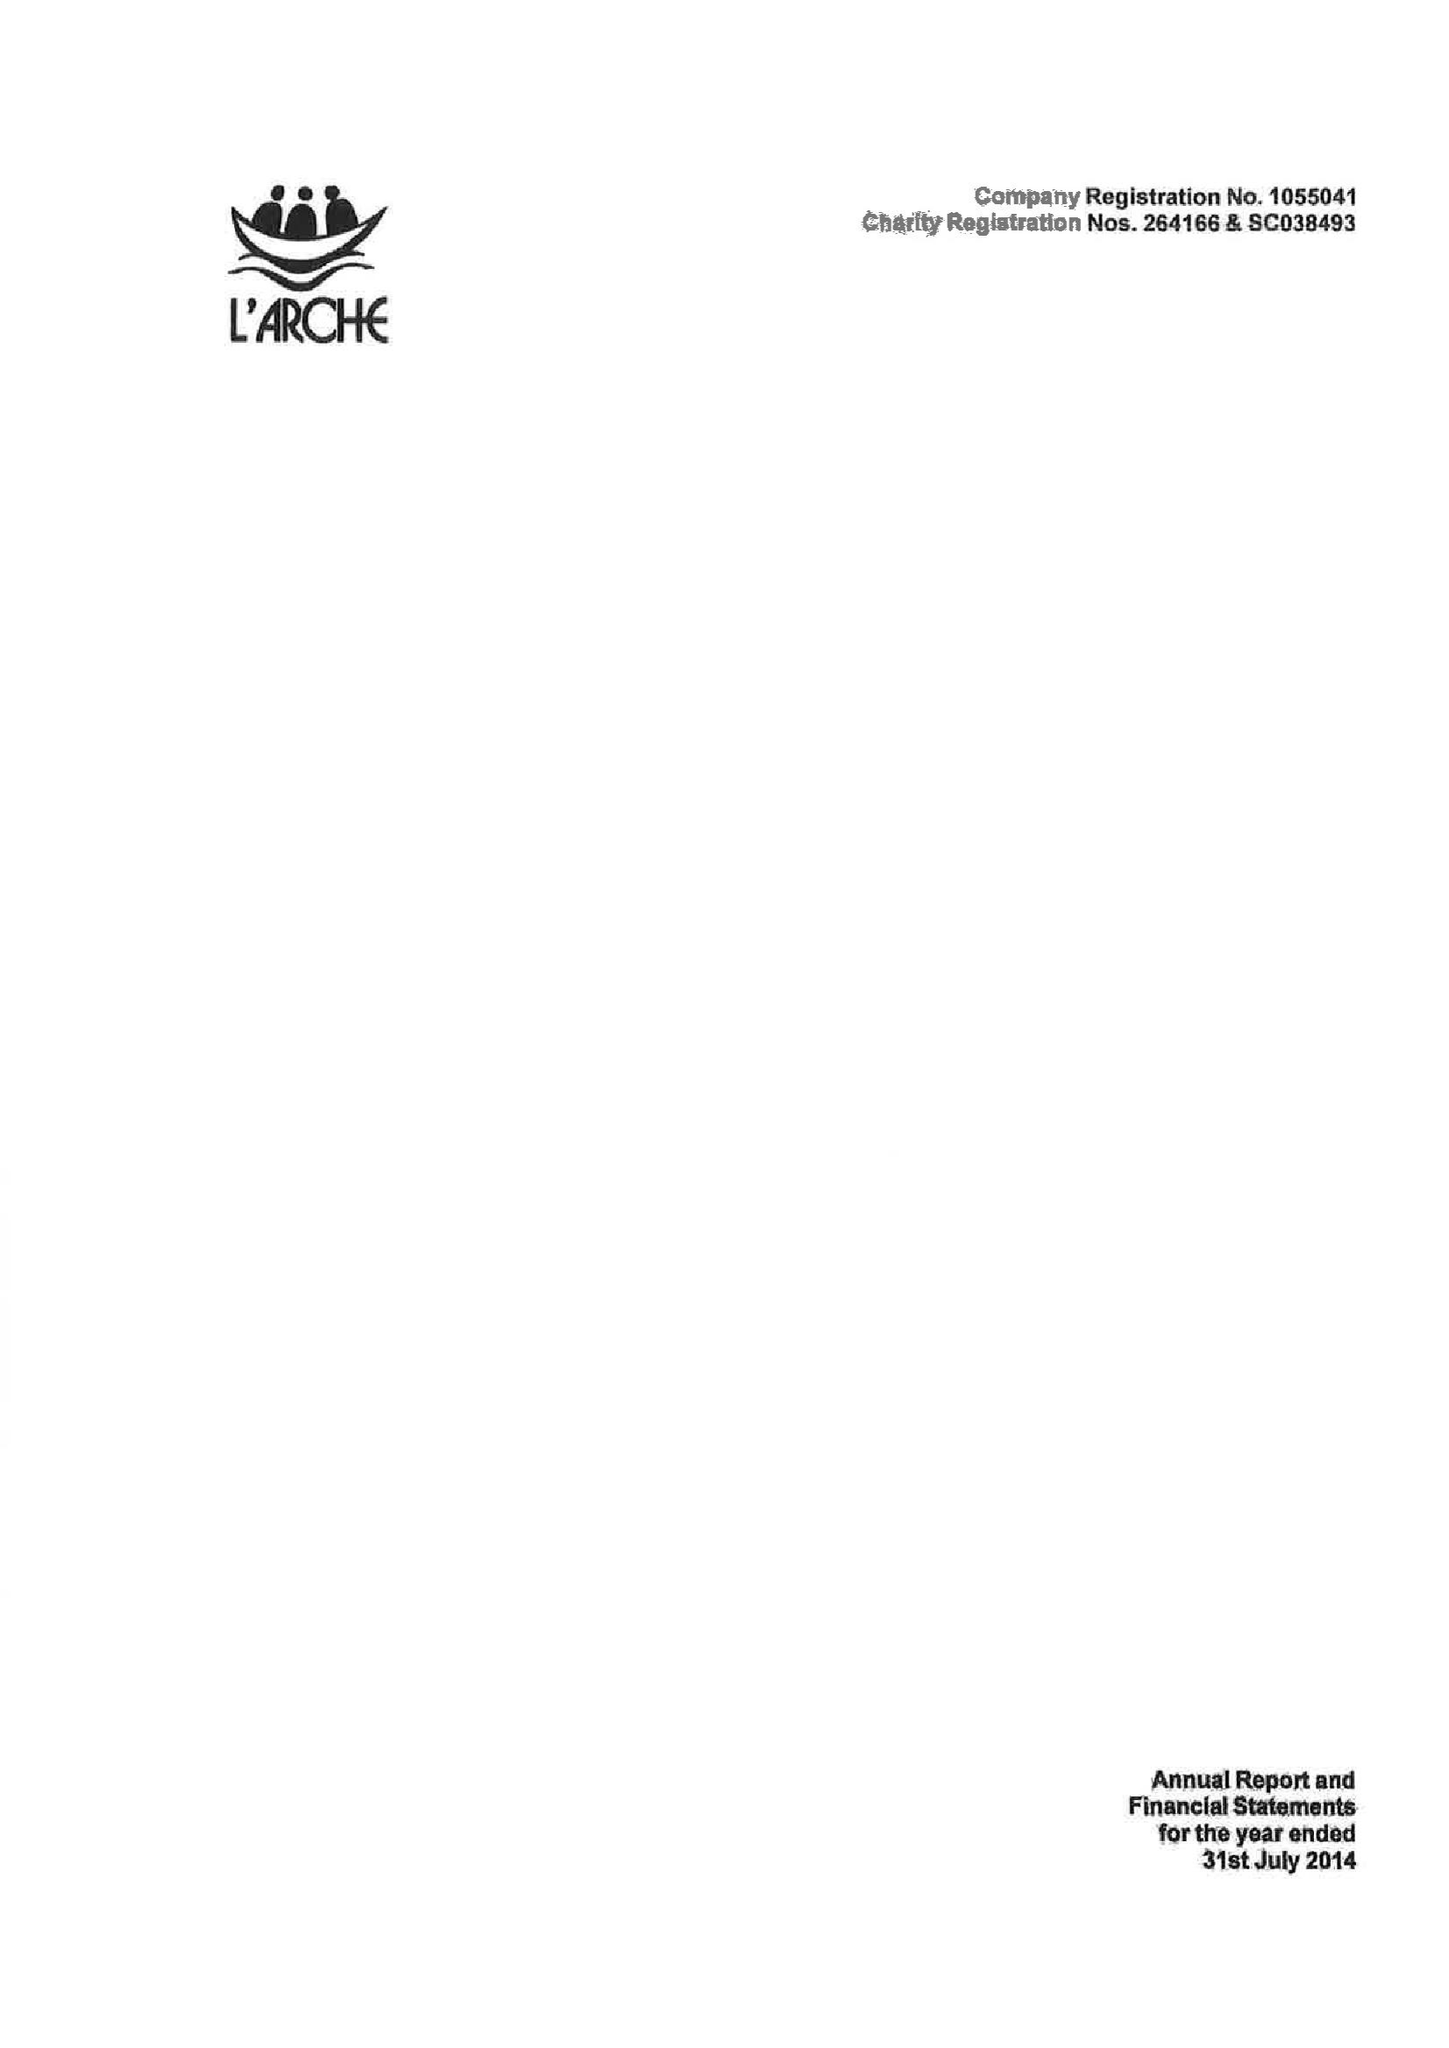What is the value for the income_annually_in_british_pounds?
Answer the question using a single word or phrase. 8669250.00 